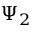Convert formula to latex. <formula><loc_0><loc_0><loc_500><loc_500>\Psi _ { 2 }</formula> 